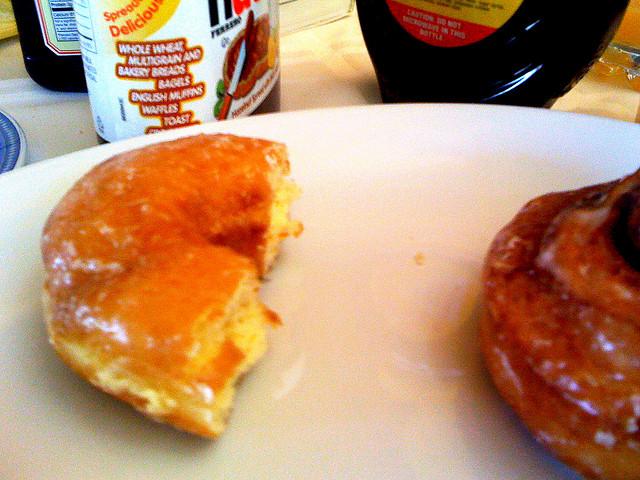Is there syrup?
Be succinct. Yes. What color is the plate?
Quick response, please. White. Did somebody take half of the donut?
Write a very short answer. Yes. 